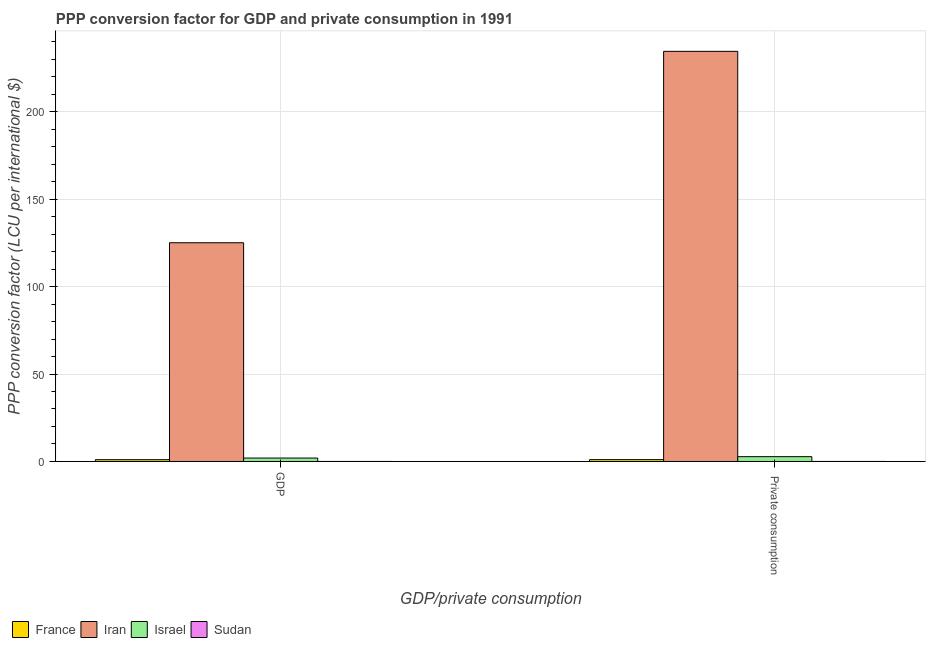How many different coloured bars are there?
Keep it short and to the point. 4. What is the label of the 1st group of bars from the left?
Offer a very short reply. GDP. What is the ppp conversion factor for private consumption in Iran?
Provide a succinct answer. 234.46. Across all countries, what is the maximum ppp conversion factor for gdp?
Keep it short and to the point. 125.03. Across all countries, what is the minimum ppp conversion factor for gdp?
Your answer should be compact. 0.01. In which country was the ppp conversion factor for gdp maximum?
Make the answer very short. Iran. In which country was the ppp conversion factor for private consumption minimum?
Keep it short and to the point. Sudan. What is the total ppp conversion factor for private consumption in the graph?
Give a very brief answer. 238.26. What is the difference between the ppp conversion factor for private consumption in Israel and that in France?
Keep it short and to the point. 1.7. What is the difference between the ppp conversion factor for private consumption in Iran and the ppp conversion factor for gdp in France?
Provide a short and direct response. 233.43. What is the average ppp conversion factor for gdp per country?
Your answer should be very brief. 32.01. What is the difference between the ppp conversion factor for private consumption and ppp conversion factor for gdp in Israel?
Your response must be concise. 0.78. In how many countries, is the ppp conversion factor for gdp greater than 60 LCU?
Make the answer very short. 1. What is the ratio of the ppp conversion factor for gdp in Iran to that in Israel?
Offer a very short reply. 63.61. What does the 2nd bar from the left in  Private consumption represents?
Keep it short and to the point. Iran. What does the 4th bar from the right in  Private consumption represents?
Provide a short and direct response. France. How many countries are there in the graph?
Make the answer very short. 4. Does the graph contain any zero values?
Your answer should be very brief. No. Does the graph contain grids?
Your answer should be compact. Yes. Where does the legend appear in the graph?
Provide a succinct answer. Bottom left. What is the title of the graph?
Give a very brief answer. PPP conversion factor for GDP and private consumption in 1991. What is the label or title of the X-axis?
Your answer should be compact. GDP/private consumption. What is the label or title of the Y-axis?
Give a very brief answer. PPP conversion factor (LCU per international $). What is the PPP conversion factor (LCU per international $) of France in GDP?
Give a very brief answer. 1.02. What is the PPP conversion factor (LCU per international $) in Iran in GDP?
Offer a very short reply. 125.03. What is the PPP conversion factor (LCU per international $) in Israel in GDP?
Your answer should be very brief. 1.97. What is the PPP conversion factor (LCU per international $) in Sudan in GDP?
Keep it short and to the point. 0.01. What is the PPP conversion factor (LCU per international $) of France in  Private consumption?
Your response must be concise. 1.05. What is the PPP conversion factor (LCU per international $) of Iran in  Private consumption?
Ensure brevity in your answer.  234.46. What is the PPP conversion factor (LCU per international $) of Israel in  Private consumption?
Your response must be concise. 2.75. What is the PPP conversion factor (LCU per international $) of Sudan in  Private consumption?
Give a very brief answer. 0.01. Across all GDP/private consumption, what is the maximum PPP conversion factor (LCU per international $) in France?
Make the answer very short. 1.05. Across all GDP/private consumption, what is the maximum PPP conversion factor (LCU per international $) in Iran?
Your answer should be very brief. 234.46. Across all GDP/private consumption, what is the maximum PPP conversion factor (LCU per international $) of Israel?
Keep it short and to the point. 2.75. Across all GDP/private consumption, what is the maximum PPP conversion factor (LCU per international $) of Sudan?
Keep it short and to the point. 0.01. Across all GDP/private consumption, what is the minimum PPP conversion factor (LCU per international $) of France?
Offer a very short reply. 1.02. Across all GDP/private consumption, what is the minimum PPP conversion factor (LCU per international $) of Iran?
Ensure brevity in your answer.  125.03. Across all GDP/private consumption, what is the minimum PPP conversion factor (LCU per international $) of Israel?
Ensure brevity in your answer.  1.97. Across all GDP/private consumption, what is the minimum PPP conversion factor (LCU per international $) of Sudan?
Keep it short and to the point. 0.01. What is the total PPP conversion factor (LCU per international $) in France in the graph?
Make the answer very short. 2.07. What is the total PPP conversion factor (LCU per international $) of Iran in the graph?
Your answer should be very brief. 359.49. What is the total PPP conversion factor (LCU per international $) of Israel in the graph?
Ensure brevity in your answer.  4.71. What is the difference between the PPP conversion factor (LCU per international $) in France in GDP and that in  Private consumption?
Keep it short and to the point. -0.03. What is the difference between the PPP conversion factor (LCU per international $) in Iran in GDP and that in  Private consumption?
Offer a very short reply. -109.42. What is the difference between the PPP conversion factor (LCU per international $) in Israel in GDP and that in  Private consumption?
Make the answer very short. -0.78. What is the difference between the PPP conversion factor (LCU per international $) of Sudan in GDP and that in  Private consumption?
Ensure brevity in your answer.  -0. What is the difference between the PPP conversion factor (LCU per international $) of France in GDP and the PPP conversion factor (LCU per international $) of Iran in  Private consumption?
Offer a terse response. -233.43. What is the difference between the PPP conversion factor (LCU per international $) of France in GDP and the PPP conversion factor (LCU per international $) of Israel in  Private consumption?
Make the answer very short. -1.72. What is the difference between the PPP conversion factor (LCU per international $) of France in GDP and the PPP conversion factor (LCU per international $) of Sudan in  Private consumption?
Make the answer very short. 1.01. What is the difference between the PPP conversion factor (LCU per international $) of Iran in GDP and the PPP conversion factor (LCU per international $) of Israel in  Private consumption?
Provide a succinct answer. 122.29. What is the difference between the PPP conversion factor (LCU per international $) in Iran in GDP and the PPP conversion factor (LCU per international $) in Sudan in  Private consumption?
Offer a terse response. 125.02. What is the difference between the PPP conversion factor (LCU per international $) of Israel in GDP and the PPP conversion factor (LCU per international $) of Sudan in  Private consumption?
Provide a short and direct response. 1.96. What is the average PPP conversion factor (LCU per international $) in France per GDP/private consumption?
Offer a terse response. 1.04. What is the average PPP conversion factor (LCU per international $) of Iran per GDP/private consumption?
Make the answer very short. 179.74. What is the average PPP conversion factor (LCU per international $) of Israel per GDP/private consumption?
Keep it short and to the point. 2.36. What is the average PPP conversion factor (LCU per international $) in Sudan per GDP/private consumption?
Give a very brief answer. 0.01. What is the difference between the PPP conversion factor (LCU per international $) of France and PPP conversion factor (LCU per international $) of Iran in GDP?
Provide a short and direct response. -124.01. What is the difference between the PPP conversion factor (LCU per international $) in France and PPP conversion factor (LCU per international $) in Israel in GDP?
Your answer should be compact. -0.94. What is the difference between the PPP conversion factor (LCU per international $) in France and PPP conversion factor (LCU per international $) in Sudan in GDP?
Provide a short and direct response. 1.02. What is the difference between the PPP conversion factor (LCU per international $) of Iran and PPP conversion factor (LCU per international $) of Israel in GDP?
Ensure brevity in your answer.  123.07. What is the difference between the PPP conversion factor (LCU per international $) in Iran and PPP conversion factor (LCU per international $) in Sudan in GDP?
Give a very brief answer. 125.02. What is the difference between the PPP conversion factor (LCU per international $) in Israel and PPP conversion factor (LCU per international $) in Sudan in GDP?
Provide a succinct answer. 1.96. What is the difference between the PPP conversion factor (LCU per international $) in France and PPP conversion factor (LCU per international $) in Iran in  Private consumption?
Keep it short and to the point. -233.41. What is the difference between the PPP conversion factor (LCU per international $) in France and PPP conversion factor (LCU per international $) in Israel in  Private consumption?
Your answer should be compact. -1.7. What is the difference between the PPP conversion factor (LCU per international $) of France and PPP conversion factor (LCU per international $) of Sudan in  Private consumption?
Your answer should be very brief. 1.04. What is the difference between the PPP conversion factor (LCU per international $) in Iran and PPP conversion factor (LCU per international $) in Israel in  Private consumption?
Your response must be concise. 231.71. What is the difference between the PPP conversion factor (LCU per international $) of Iran and PPP conversion factor (LCU per international $) of Sudan in  Private consumption?
Make the answer very short. 234.44. What is the difference between the PPP conversion factor (LCU per international $) of Israel and PPP conversion factor (LCU per international $) of Sudan in  Private consumption?
Your answer should be compact. 2.74. What is the ratio of the PPP conversion factor (LCU per international $) of France in GDP to that in  Private consumption?
Ensure brevity in your answer.  0.98. What is the ratio of the PPP conversion factor (LCU per international $) in Iran in GDP to that in  Private consumption?
Your answer should be very brief. 0.53. What is the ratio of the PPP conversion factor (LCU per international $) of Israel in GDP to that in  Private consumption?
Your response must be concise. 0.72. What is the ratio of the PPP conversion factor (LCU per international $) in Sudan in GDP to that in  Private consumption?
Offer a very short reply. 0.9. What is the difference between the highest and the second highest PPP conversion factor (LCU per international $) in France?
Offer a very short reply. 0.03. What is the difference between the highest and the second highest PPP conversion factor (LCU per international $) of Iran?
Your answer should be very brief. 109.42. What is the difference between the highest and the second highest PPP conversion factor (LCU per international $) of Israel?
Offer a terse response. 0.78. What is the difference between the highest and the lowest PPP conversion factor (LCU per international $) of France?
Provide a succinct answer. 0.03. What is the difference between the highest and the lowest PPP conversion factor (LCU per international $) of Iran?
Offer a very short reply. 109.42. What is the difference between the highest and the lowest PPP conversion factor (LCU per international $) in Israel?
Provide a short and direct response. 0.78. 